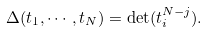Convert formula to latex. <formula><loc_0><loc_0><loc_500><loc_500>\Delta ( t _ { 1 } , \cdots , t _ { N } ) = \det ( t _ { i } ^ { N - j } ) .</formula> 